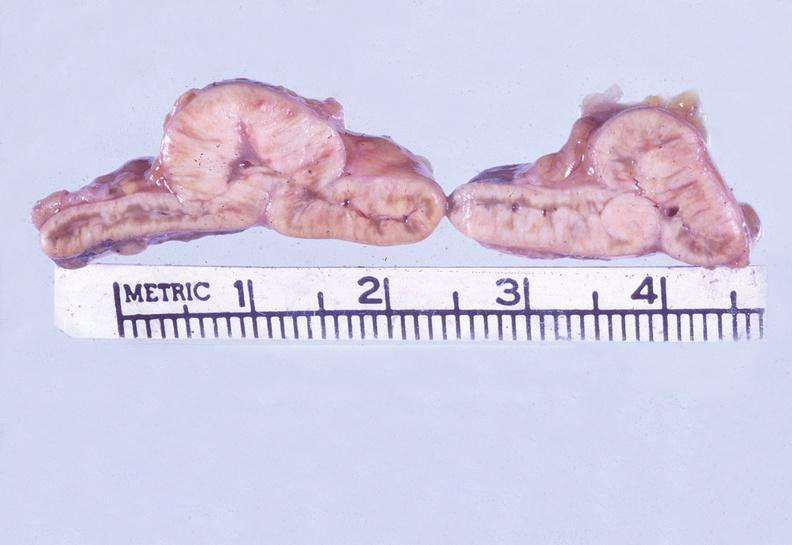s surface present?
Answer the question using a single word or phrase. No 